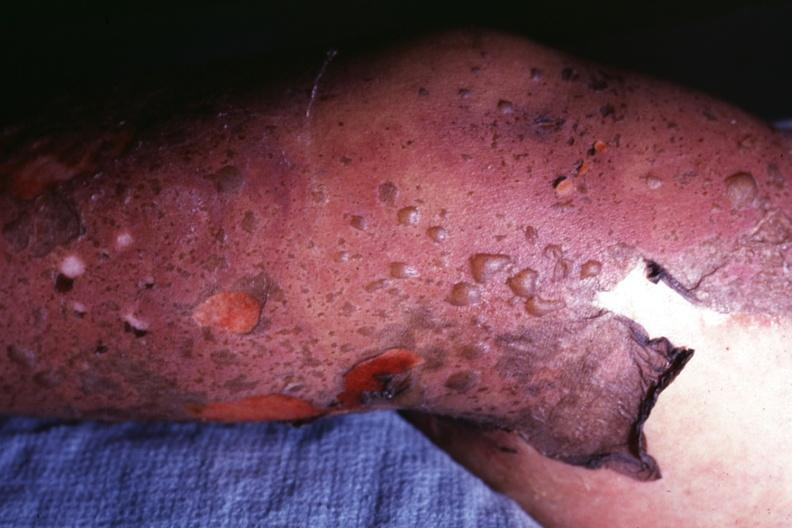s this correct diagnosis as i do not have protocol?
Answer the question using a single word or phrase. Yes 